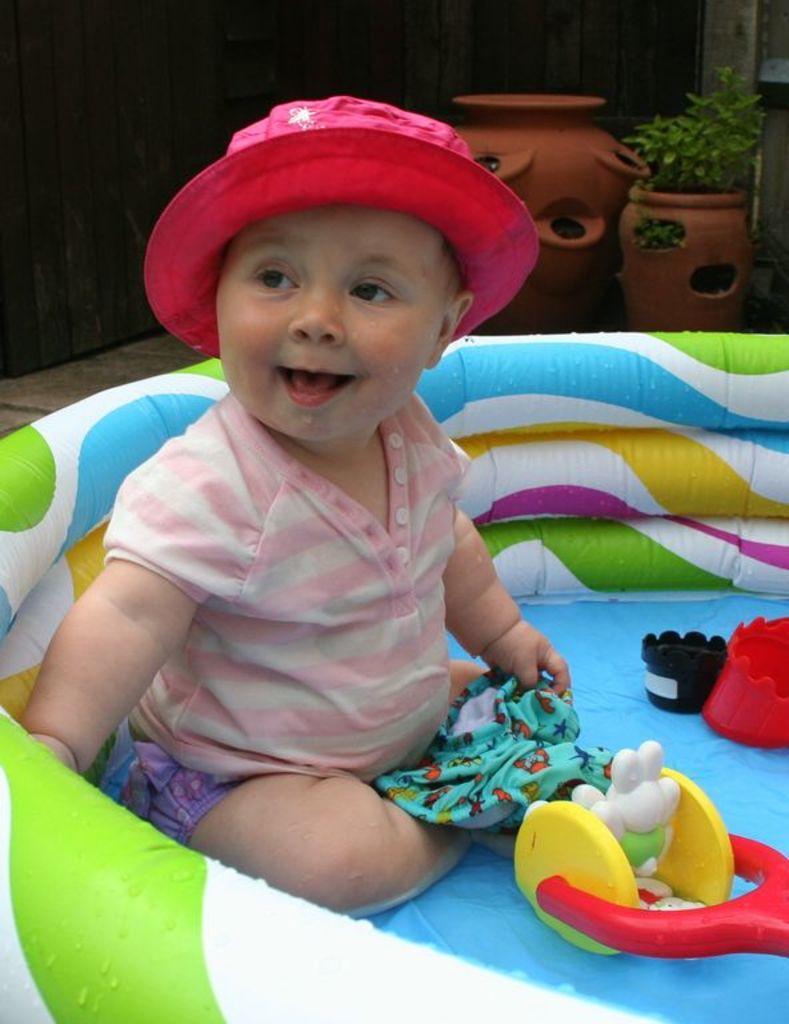Can you describe this image briefly? In this image I can see a baby is sitting in a object. The baby is wearing a hat hand holding some object. Here I can see toys. In the background I can see pots and other objects. 